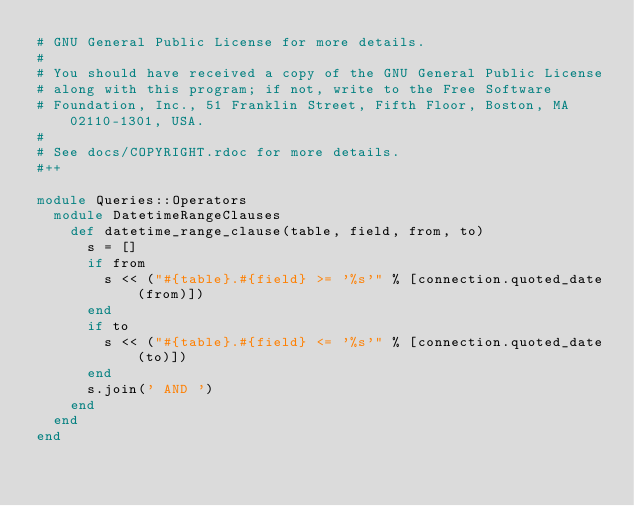Convert code to text. <code><loc_0><loc_0><loc_500><loc_500><_Ruby_># GNU General Public License for more details.
#
# You should have received a copy of the GNU General Public License
# along with this program; if not, write to the Free Software
# Foundation, Inc., 51 Franklin Street, Fifth Floor, Boston, MA  02110-1301, USA.
#
# See docs/COPYRIGHT.rdoc for more details.
#++

module Queries::Operators
  module DatetimeRangeClauses
    def datetime_range_clause(table, field, from, to)
      s = []
      if from
        s << ("#{table}.#{field} >= '%s'" % [connection.quoted_date(from)])
      end
      if to
        s << ("#{table}.#{field} <= '%s'" % [connection.quoted_date(to)])
      end
      s.join(' AND ')
    end
  end
end
</code> 